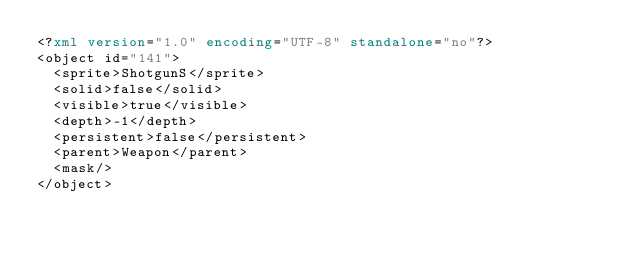<code> <loc_0><loc_0><loc_500><loc_500><_XML_><?xml version="1.0" encoding="UTF-8" standalone="no"?>
<object id="141">
  <sprite>ShotgunS</sprite>
  <solid>false</solid>
  <visible>true</visible>
  <depth>-1</depth>
  <persistent>false</persistent>
  <parent>Weapon</parent>
  <mask/>
</object>
</code> 